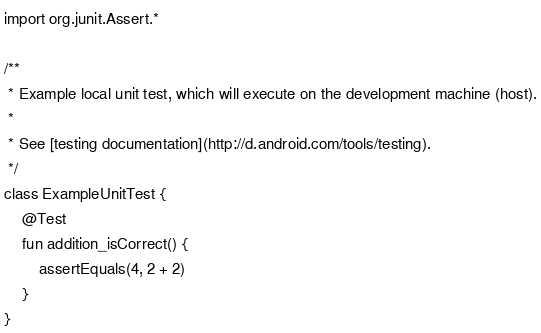Convert code to text. <code><loc_0><loc_0><loc_500><loc_500><_Kotlin_>import org.junit.Assert.*

/**
 * Example local unit test, which will execute on the development machine (host).
 *
 * See [testing documentation](http://d.android.com/tools/testing).
 */
class ExampleUnitTest {
    @Test
    fun addition_isCorrect() {
        assertEquals(4, 2 + 2)
    }
}</code> 